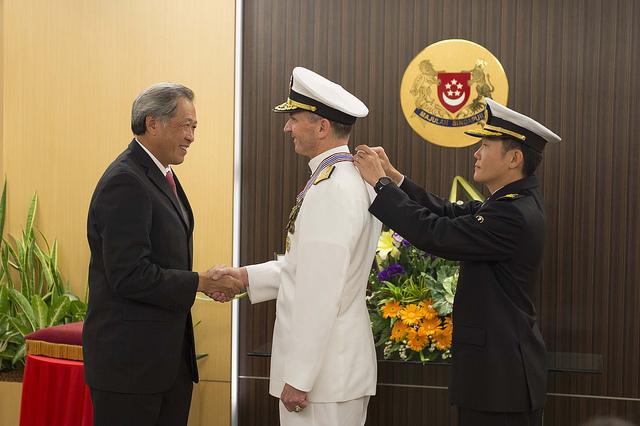Is someone getting an award?
Be succinct. Yes. How many men are not wearing hats?
Answer briefly. 1. What kind of flower is orange?
Short answer required. Daisy. 